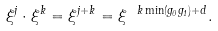<formula> <loc_0><loc_0><loc_500><loc_500>\xi ^ { j } \cdot \xi ^ { k } = \xi ^ { j + k } = \xi ^ { \ k \min ( g _ { 0 } g _ { 1 } ) + d } .</formula> 